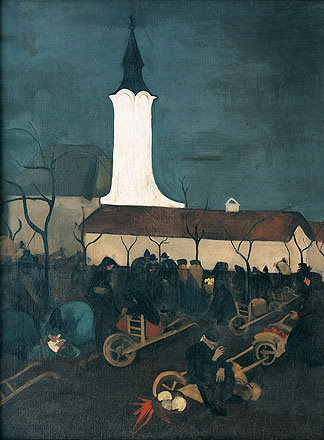What might the activities of the people around the church suggest about this community? The activities depicted—people carrying tools and engaging in physical labor—suggest a tightly-knit community engaged in collective efforts, possibly preparing for a communal event or participating in a ritual. Such involvement indicates strong community bonds and a shared responsibility in upkeep and celebration of communal spaces, reflecting the integral role of the church and community gatherings in their social and spiritual lives. 